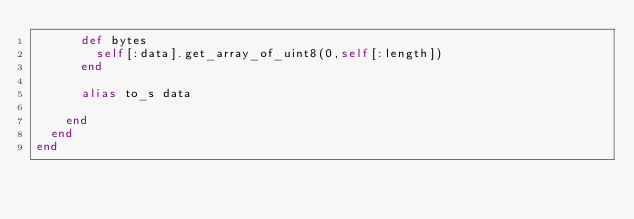Convert code to text. <code><loc_0><loc_0><loc_500><loc_500><_Ruby_>      def bytes
        self[:data].get_array_of_uint8(0,self[:length])
      end

      alias to_s data

    end
  end
end
</code> 